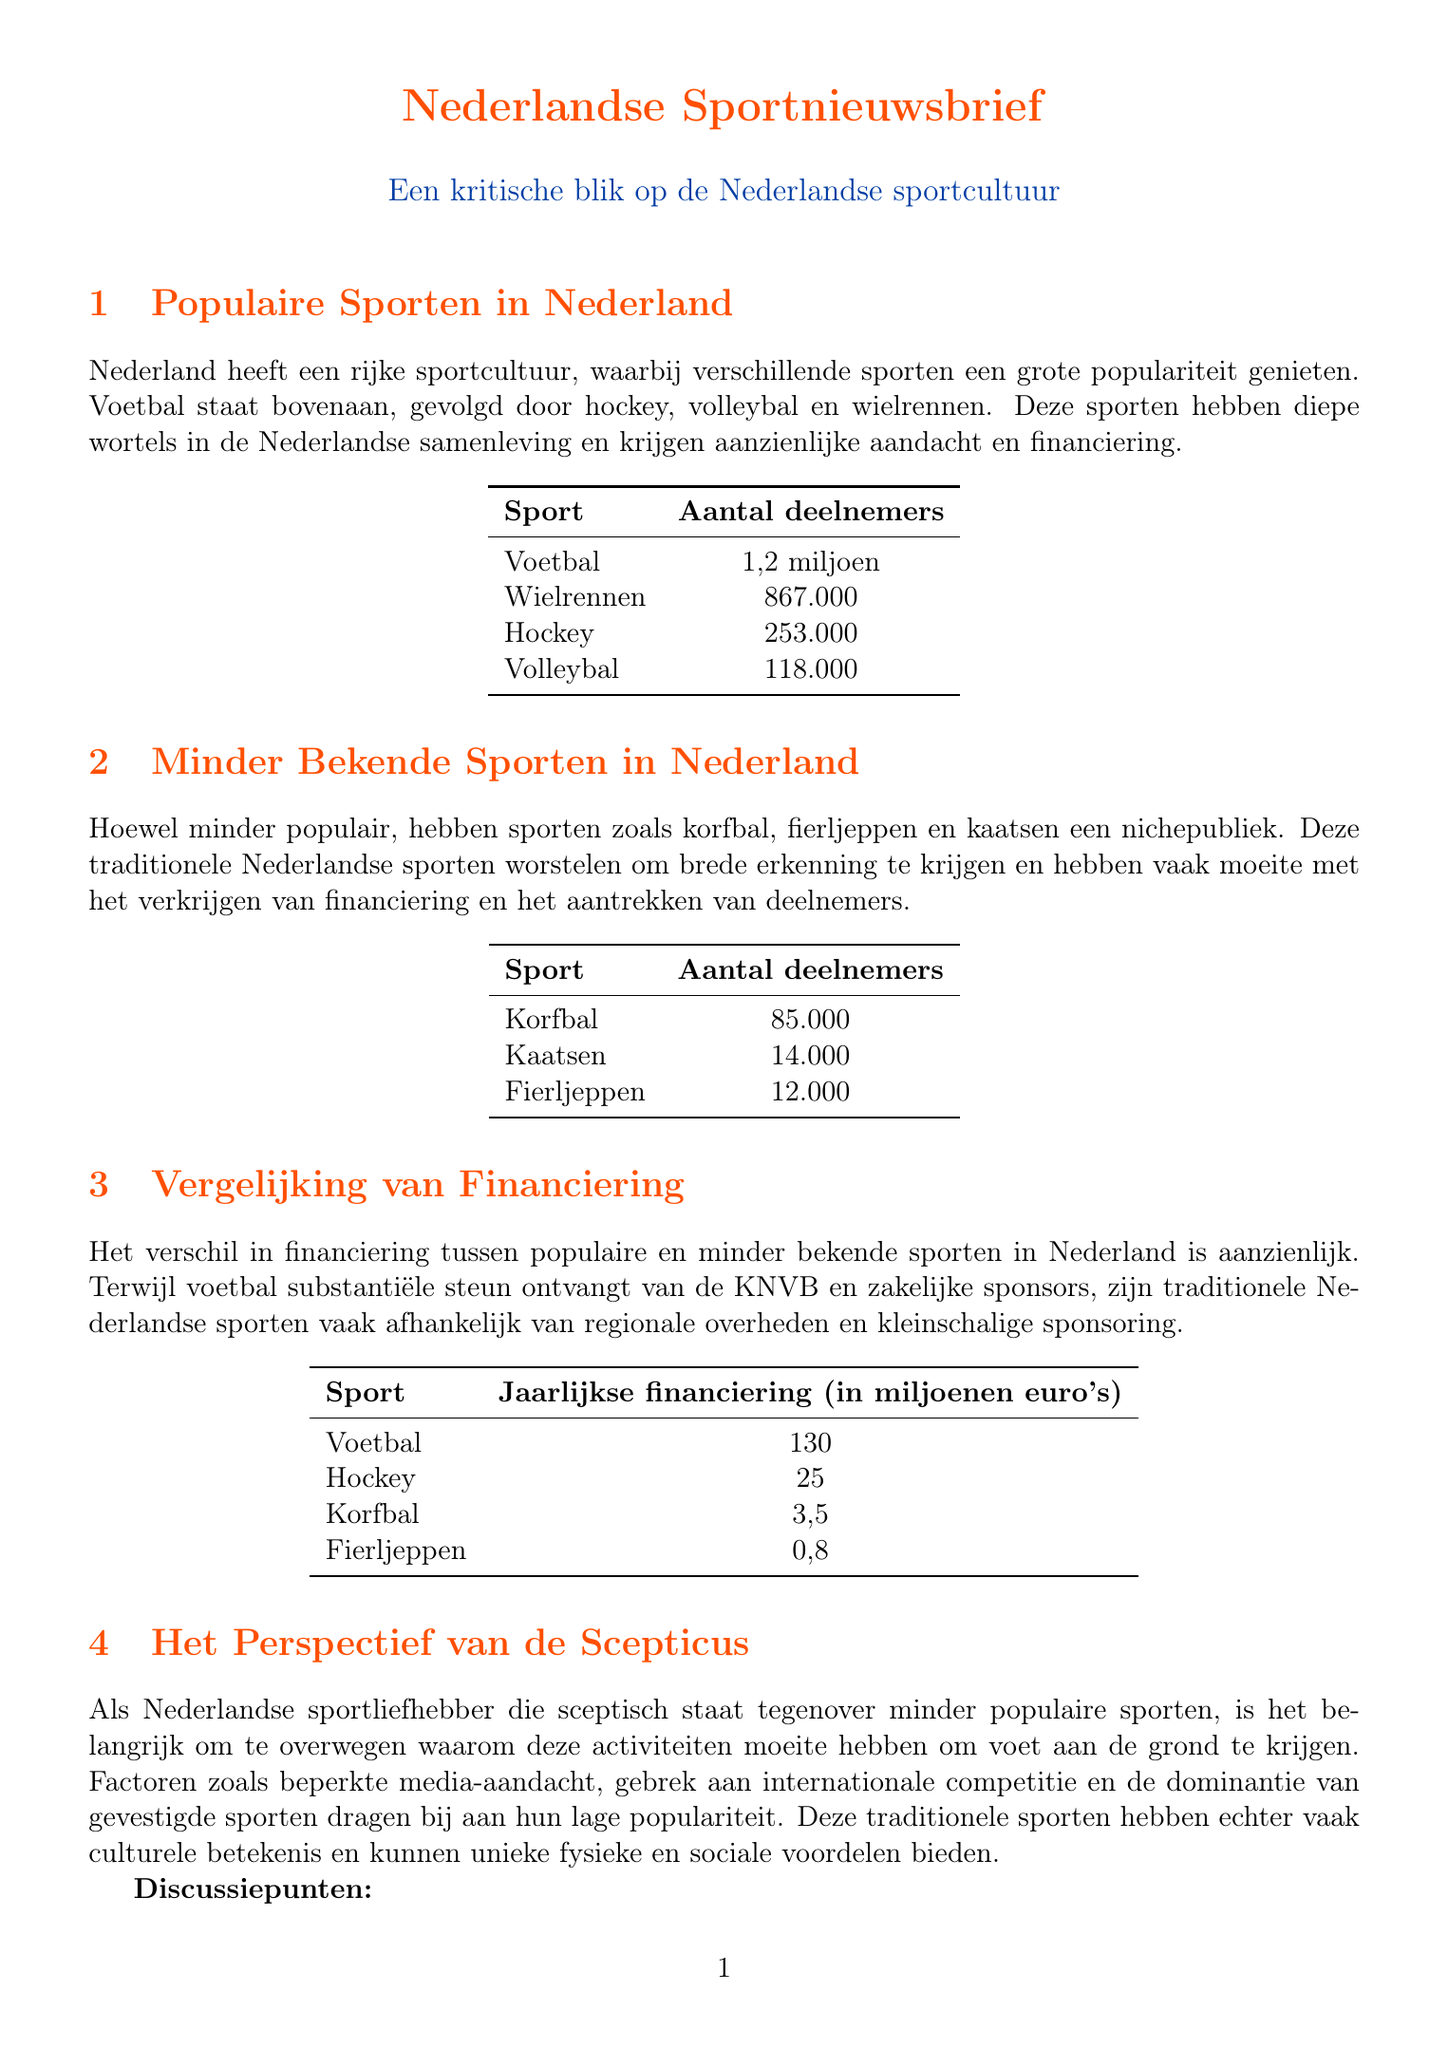What sport has the highest participation rate in the Netherlands? The participation rates for sports in the Netherlands show that football has the highest participation rate at 1.2 million.
Answer: Football How many participants are there in korfball? The document states that korfball has 85,000 participants.
Answer: 85,000 What is the annual funding for fiercejeppen? The funding comparison infographic indicates that fiercejeppen receives 0.8 million euros annually.
Answer: 0.8 How many Olympic medals has the Netherlands won in traditional Dutch sports since 2000? The document notes that there have been 0 Olympic medals won in traditional Dutch sports since 2000.
Answer: 0 What percentage of sports funding is allocated to the top 5 popular sports? According to the key statistics section, 68% of sports funding is allocated to the top 5 popular sports.
Answer: 68% Which sport receives the most annual funding? The funding section indicates that football receives the most annual funding at 130 million euros.
Answer: 130 What is the participation rate for fiercejeppen? The participation rate for fiercejeppen is stated to be 12,000.
Answer: 12,000 What is a key reason for the low popularity of lesser-known sports? The document outlines that factors such as limited media coverage contribute to low popularity.
Answer: Limited media coverage How many participants are there in kaatsen? The content states that kaatsen has 14,000 participants.
Answer: 14,000 